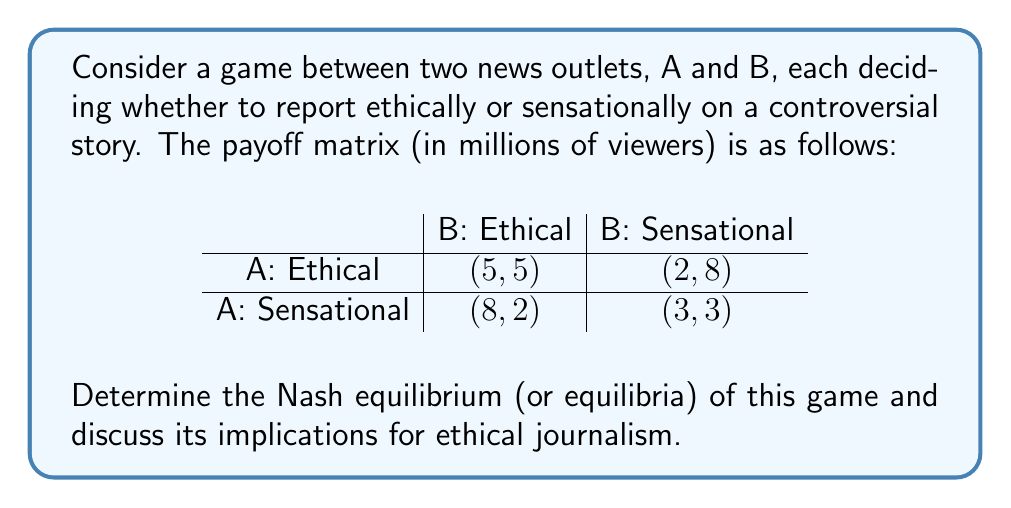Give your solution to this math problem. To find the Nash equilibrium, we need to analyze each player's best response to the other player's strategy:

1. For News Outlet A:
   - If B chooses Ethical, A's best response is Sensational (8 > 5)
   - If B chooses Sensational, A's best response is Ethical (2 > 3)

2. For News Outlet B:
   - If A chooses Ethical, B's best response is Sensational (8 > 5)
   - If A chooses Sensational, B's best response is Ethical (2 > 3)

We can see that there is no pure strategy Nash equilibrium, as no pair of strategies is a best response to each other.

To find the mixed strategy Nash equilibrium, let's define:
$p$ = probability that A chooses Ethical
$q$ = probability that B chooses Ethical

For A to be indifferent between strategies:
$5q + 2(1-q) = 8q + 3(1-q)$
$5q + 2 - 2q = 8q + 3 - 3q$
$3q + 2 = 5q + 3$
$-2q = 1$
$q = \frac{1}{2}$

Similarly, for B to be indifferent:
$5p + 2(1-p) = 8p + 3(1-p)$
$5p + 2 - 2p = 8p + 3 - 3p$
$3p + 2 = 5p + 3$
$-2p = 1$
$p = \frac{1}{2}$

Therefore, the mixed strategy Nash equilibrium is $(p, q) = (\frac{1}{2}, \frac{1}{2})$.

Implications for ethical journalism:
1. Neither outlet has a dominant strategy to always report ethically or sensationally.
2. In equilibrium, both outlets will randomize between ethical and sensational reporting with equal probability.
3. This results in an expected payoff of 4.5 million viewers for each outlet, which is less than the 5 million they would get if both always reported ethically.
4. The competitive nature of news reporting creates a "prisoner's dilemma"-like situation, where the pursuit of higher viewership can lead to less ethical reporting overall.
Answer: The Nash equilibrium is a mixed strategy equilibrium where both news outlets choose to report ethically with probability $\frac{1}{2}$ and sensationally with probability $\frac{1}{2}$. This results in an expected payoff of 4.5 million viewers for each outlet. 